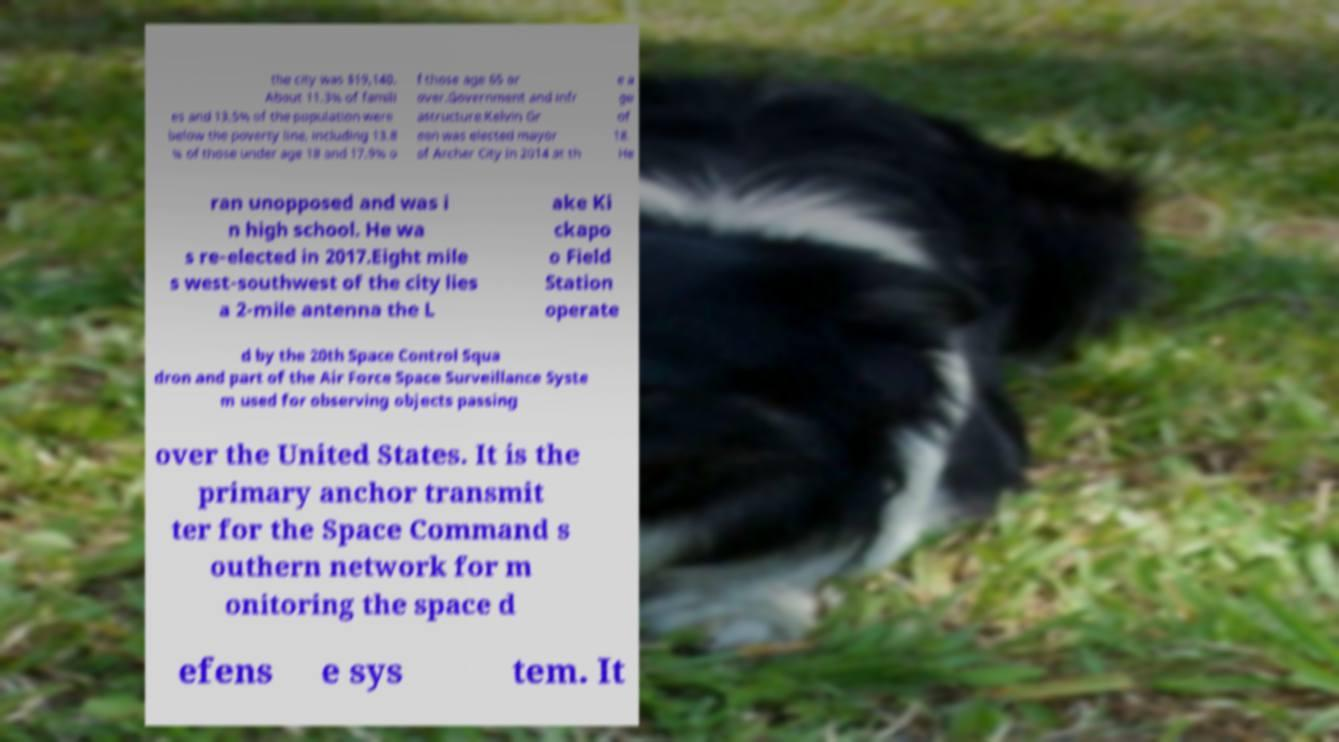Can you accurately transcribe the text from the provided image for me? the city was $19,140. About 11.3% of famili es and 13.5% of the population were below the poverty line, including 13.8 % of those under age 18 and 17.9% o f those age 65 or over.Government and infr astructure.Kelvin Gr een was elected mayor of Archer City in 2014 at th e a ge of 18. He ran unopposed and was i n high school. He wa s re-elected in 2017.Eight mile s west-southwest of the city lies a 2-mile antenna the L ake Ki ckapo o Field Station operate d by the 20th Space Control Squa dron and part of the Air Force Space Surveillance Syste m used for observing objects passing over the United States. It is the primary anchor transmit ter for the Space Command s outhern network for m onitoring the space d efens e sys tem. It 